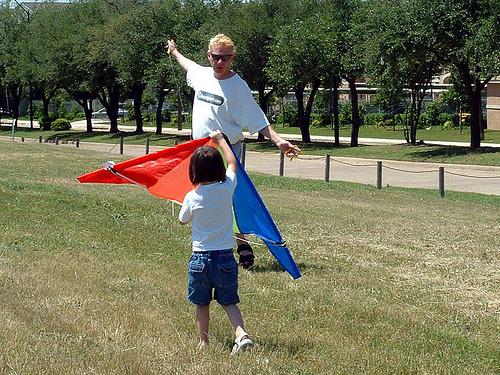What is the kite for?
Write a very short answer. Flying. Is the kite made of leather?
Write a very short answer. No. What colors are the kite?
Give a very brief answer. Red and blue. How many people are holding a kite in this scene?
Answer briefly. 1. Was the grass in this photo recently mowed?
Answer briefly. No. 